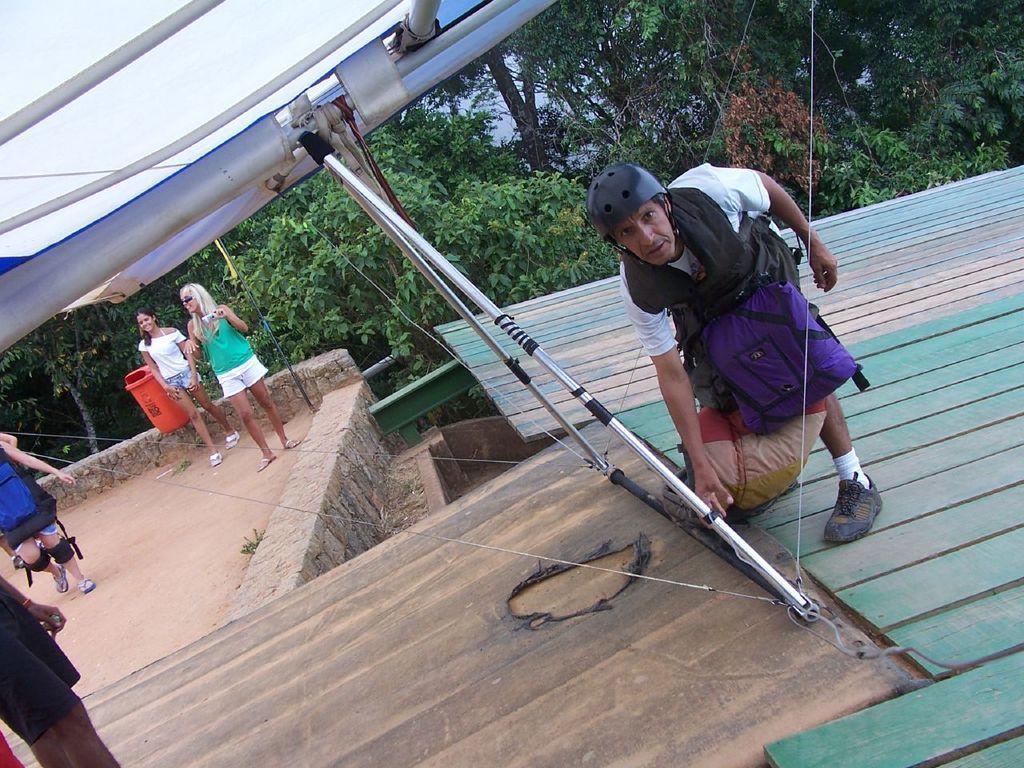Please provide a concise description of this image. In the picture I can see people are standing on the ground among them the man on the right side is standing on a wooden surface and wearing a helmet. In the background I can see trees and some other objects. 